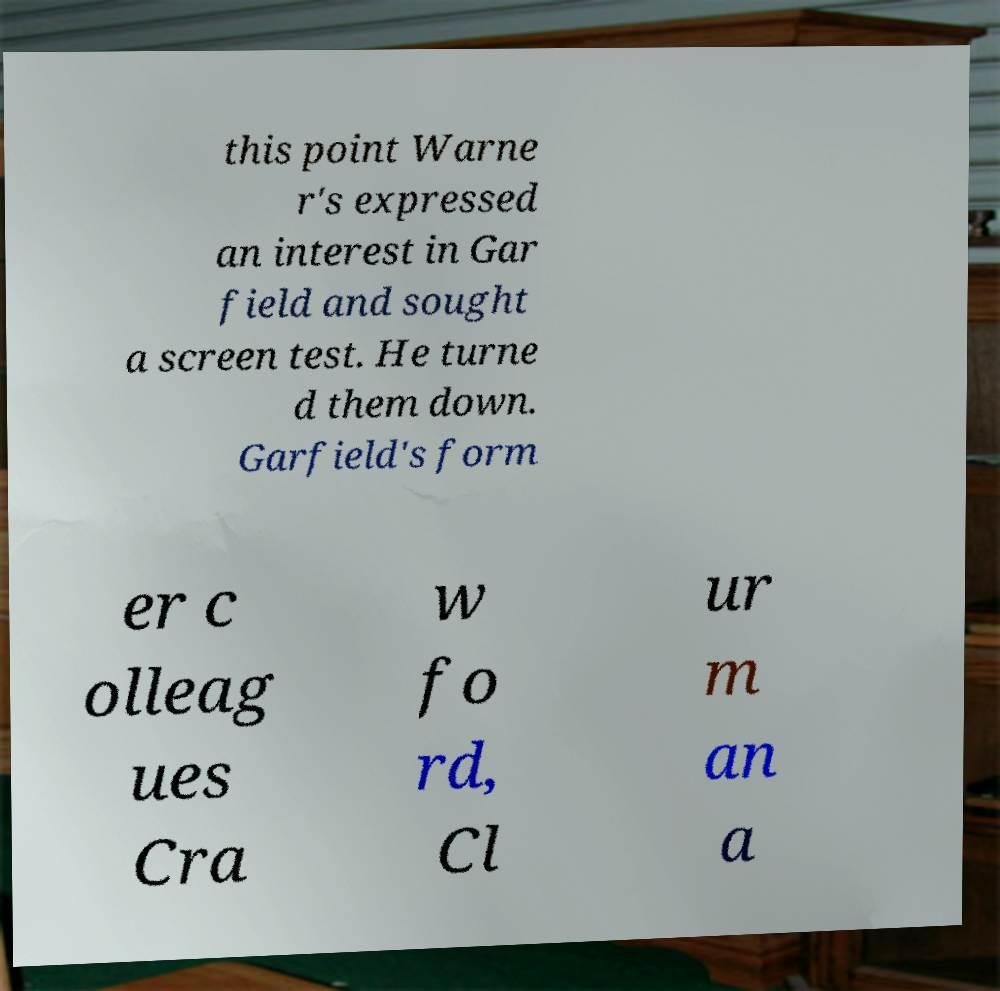Could you assist in decoding the text presented in this image and type it out clearly? this point Warne r's expressed an interest in Gar field and sought a screen test. He turne d them down. Garfield's form er c olleag ues Cra w fo rd, Cl ur m an a 